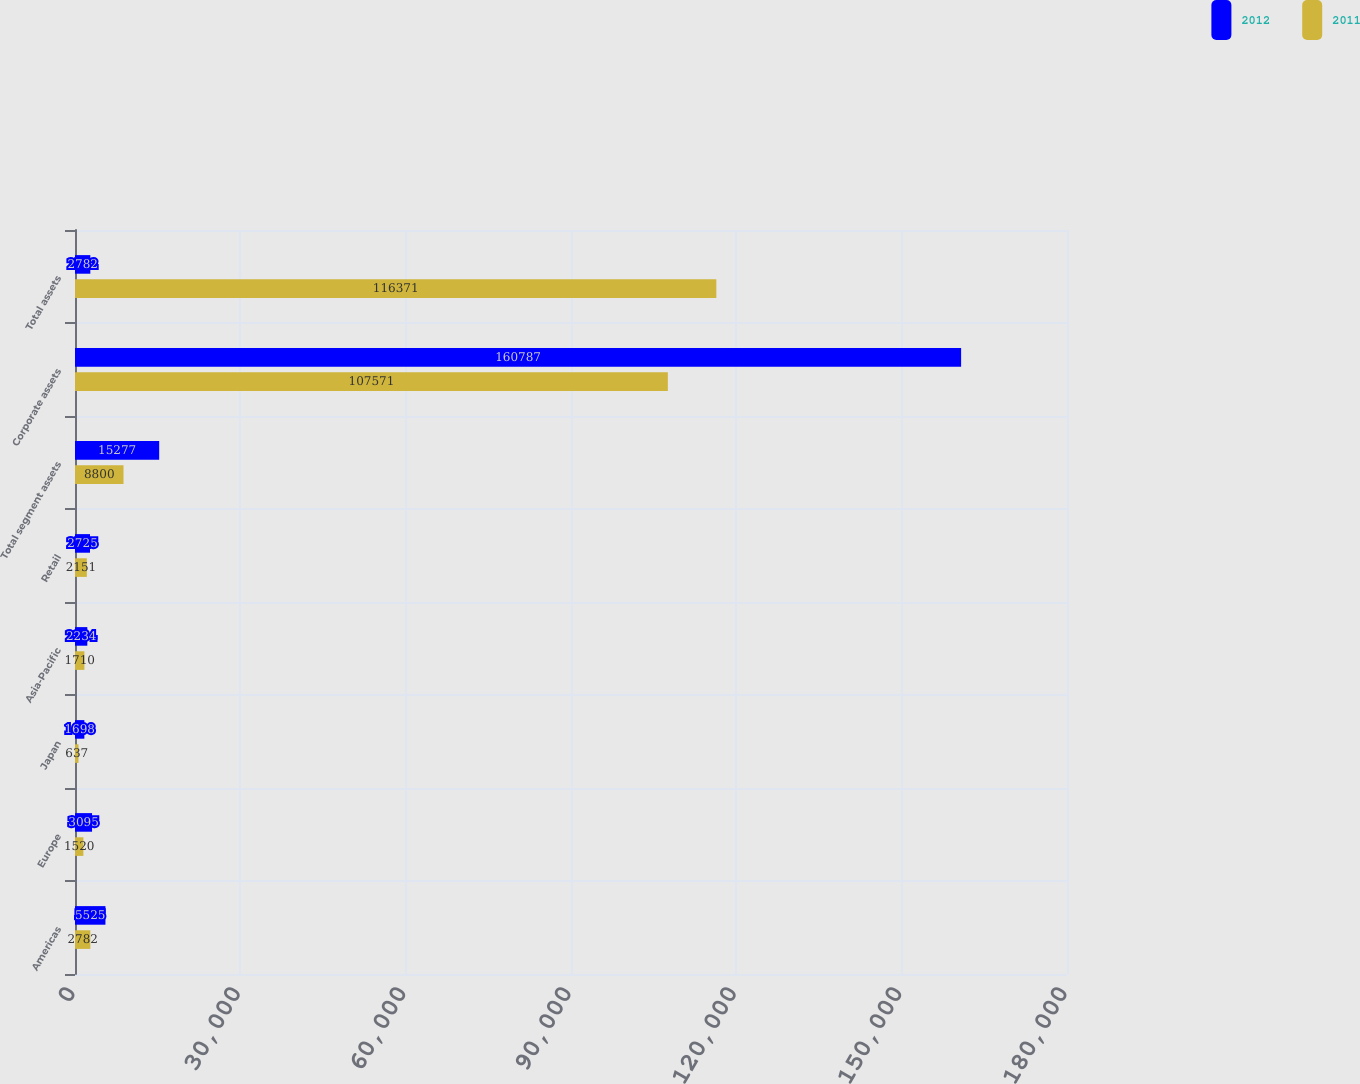<chart> <loc_0><loc_0><loc_500><loc_500><stacked_bar_chart><ecel><fcel>Americas<fcel>Europe<fcel>Japan<fcel>Asia-Pacific<fcel>Retail<fcel>Total segment assets<fcel>Corporate assets<fcel>Total assets<nl><fcel>2012<fcel>5525<fcel>3095<fcel>1698<fcel>2234<fcel>2725<fcel>15277<fcel>160787<fcel>2782<nl><fcel>2011<fcel>2782<fcel>1520<fcel>637<fcel>1710<fcel>2151<fcel>8800<fcel>107571<fcel>116371<nl></chart> 